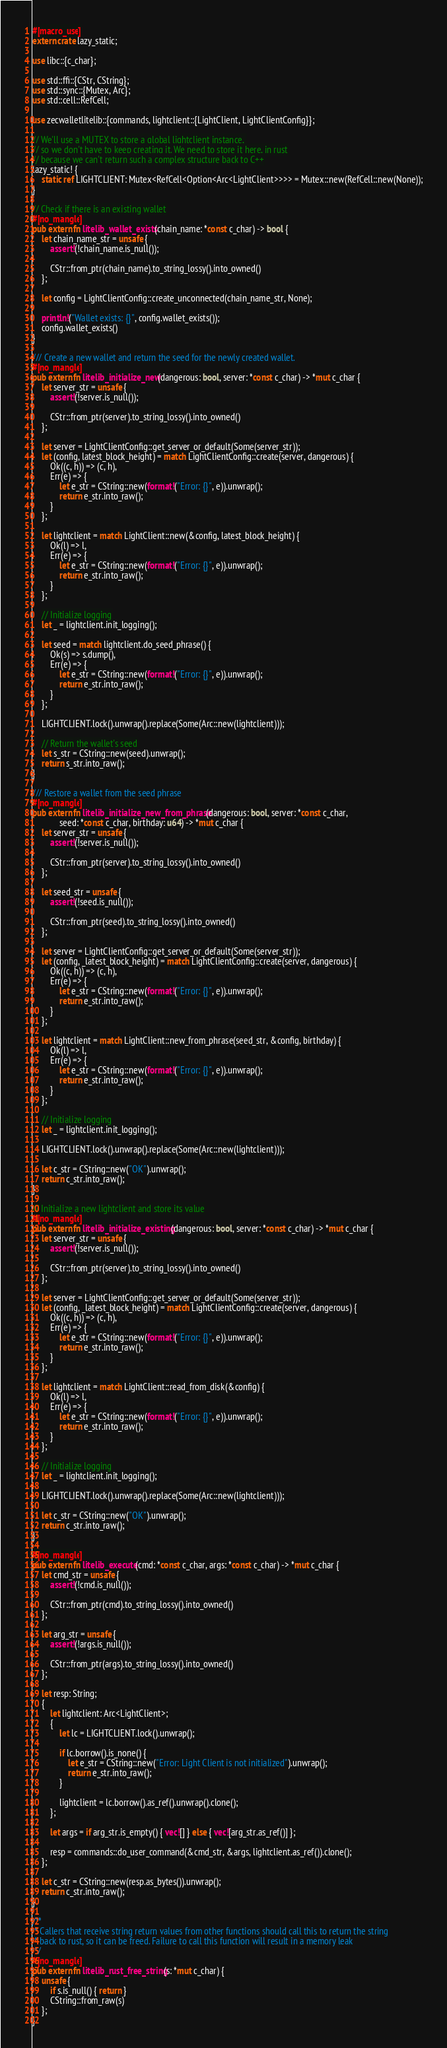Convert code to text. <code><loc_0><loc_0><loc_500><loc_500><_Rust_>#[macro_use]
extern crate lazy_static;

use libc::{c_char};

use std::ffi::{CStr, CString};
use std::sync::{Mutex, Arc};
use std::cell::RefCell;

use zecwalletlitelib::{commands, lightclient::{LightClient, LightClientConfig}};

// We'll use a MUTEX to store a global lightclient instance, 
// so we don't have to keep creating it. We need to store it here, in rust
// because we can't return such a complex structure back to C++
lazy_static! {
    static ref LIGHTCLIENT: Mutex<RefCell<Option<Arc<LightClient>>>> = Mutex::new(RefCell::new(None));
}

// Check if there is an existing wallet
#[no_mangle]
pub extern fn litelib_wallet_exists(chain_name: *const c_char) -> bool {
    let chain_name_str = unsafe {
        assert!(!chain_name.is_null());

        CStr::from_ptr(chain_name).to_string_lossy().into_owned()
    };

    let config = LightClientConfig::create_unconnected(chain_name_str, None);

    println!("Wallet exists: {}", config.wallet_exists());
    config.wallet_exists()
}

/// Create a new wallet and return the seed for the newly created wallet.
#[no_mangle]
pub extern fn litelib_initialize_new(dangerous: bool, server: *const c_char) -> *mut c_char {
    let server_str = unsafe {
        assert!(!server.is_null());

        CStr::from_ptr(server).to_string_lossy().into_owned()
    };

    let server = LightClientConfig::get_server_or_default(Some(server_str));
    let (config, latest_block_height) = match LightClientConfig::create(server, dangerous) {
        Ok((c, h)) => (c, h),
        Err(e) => {
            let e_str = CString::new(format!("Error: {}", e)).unwrap();
            return e_str.into_raw();
        }
    };

    let lightclient = match LightClient::new(&config, latest_block_height) {
        Ok(l) => l,
        Err(e) => {
            let e_str = CString::new(format!("Error: {}", e)).unwrap();
            return e_str.into_raw();
        }
    };

    // Initialize logging
    let _ = lightclient.init_logging();

    let seed = match lightclient.do_seed_phrase() {
        Ok(s) => s.dump(),
        Err(e) => {
            let e_str = CString::new(format!("Error: {}", e)).unwrap();
            return e_str.into_raw();
        }
    };

    LIGHTCLIENT.lock().unwrap().replace(Some(Arc::new(lightclient)));

    // Return the wallet's seed
    let s_str = CString::new(seed).unwrap();
    return s_str.into_raw();
}

/// Restore a wallet from the seed phrase
#[no_mangle]
pub extern fn litelib_initialize_new_from_phrase(dangerous: bool, server: *const c_char, 
            seed: *const c_char, birthday: u64) -> *mut c_char {
    let server_str = unsafe {
        assert!(!server.is_null());

        CStr::from_ptr(server).to_string_lossy().into_owned()
    };

    let seed_str = unsafe {
        assert!(!seed.is_null());

        CStr::from_ptr(seed).to_string_lossy().into_owned()
    };

    let server = LightClientConfig::get_server_or_default(Some(server_str));
    let (config, _latest_block_height) = match LightClientConfig::create(server, dangerous) {
        Ok((c, h)) => (c, h),
        Err(e) => {
            let e_str = CString::new(format!("Error: {}", e)).unwrap();
            return e_str.into_raw();
        }
    };

    let lightclient = match LightClient::new_from_phrase(seed_str, &config, birthday) {
        Ok(l) => l,
        Err(e) => {
            let e_str = CString::new(format!("Error: {}", e)).unwrap();
            return e_str.into_raw();
        }
    };

    // Initialize logging
    let _ = lightclient.init_logging();

    LIGHTCLIENT.lock().unwrap().replace(Some(Arc::new(lightclient)));
 
    let c_str = CString::new("OK").unwrap();
    return c_str.into_raw();
}

// Initialize a new lightclient and store its value
#[no_mangle]
pub extern fn litelib_initialize_existing(dangerous: bool, server: *const c_char) -> *mut c_char {
    let server_str = unsafe {
        assert!(!server.is_null());

        CStr::from_ptr(server).to_string_lossy().into_owned()
    };

    let server = LightClientConfig::get_server_or_default(Some(server_str));
    let (config, _latest_block_height) = match LightClientConfig::create(server, dangerous) {
        Ok((c, h)) => (c, h),
        Err(e) => {
            let e_str = CString::new(format!("Error: {}", e)).unwrap();
            return e_str.into_raw();
        }
    };

    let lightclient = match LightClient::read_from_disk(&config) {
        Ok(l) => l,
        Err(e) => {
            let e_str = CString::new(format!("Error: {}", e)).unwrap();
            return e_str.into_raw();
        }
    };

    // Initialize logging
    let _ = lightclient.init_logging();

    LIGHTCLIENT.lock().unwrap().replace(Some(Arc::new(lightclient)));

    let c_str = CString::new("OK").unwrap();
    return c_str.into_raw();
}

#[no_mangle]
pub extern fn litelib_execute(cmd: *const c_char, args: *const c_char) -> *mut c_char {
    let cmd_str = unsafe {
        assert!(!cmd.is_null());

        CStr::from_ptr(cmd).to_string_lossy().into_owned()
    };

    let arg_str = unsafe {
        assert!(!args.is_null());

        CStr::from_ptr(args).to_string_lossy().into_owned()
    };

    let resp: String;
    {
        let lightclient: Arc<LightClient>;
        {
            let lc = LIGHTCLIENT.lock().unwrap();

            if lc.borrow().is_none() {
                let e_str = CString::new("Error: Light Client is not initialized").unwrap();
                return e_str.into_raw();
            }

            lightclient = lc.borrow().as_ref().unwrap().clone();
        };

        let args = if arg_str.is_empty() { vec![] } else { vec![arg_str.as_ref()] };

        resp = commands::do_user_command(&cmd_str, &args, lightclient.as_ref()).clone();
    };

    let c_str = CString::new(resp.as_bytes()).unwrap();
    return c_str.into_raw();
}

/**
 * Callers that receive string return values from other functions should call this to return the string 
 * back to rust, so it can be freed. Failure to call this function will result in a memory leak
 */ 
#[no_mangle]
pub extern fn litelib_rust_free_string(s: *mut c_char) {
    unsafe {
        if s.is_null() { return }
        CString::from_raw(s)
    };
}</code> 